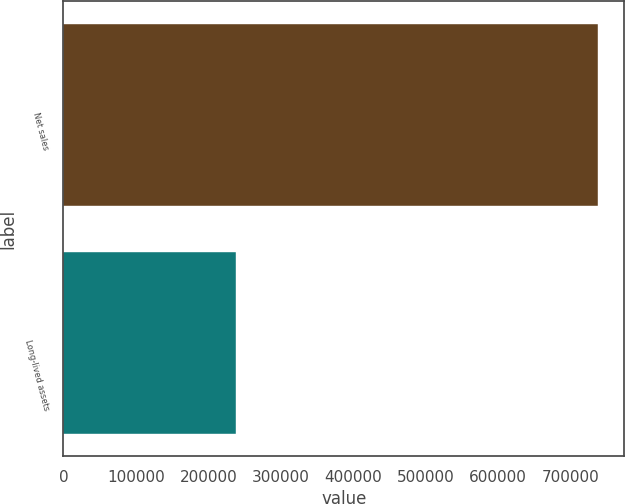<chart> <loc_0><loc_0><loc_500><loc_500><bar_chart><fcel>Net sales<fcel>Long-lived assets<nl><fcel>737018<fcel>237891<nl></chart> 